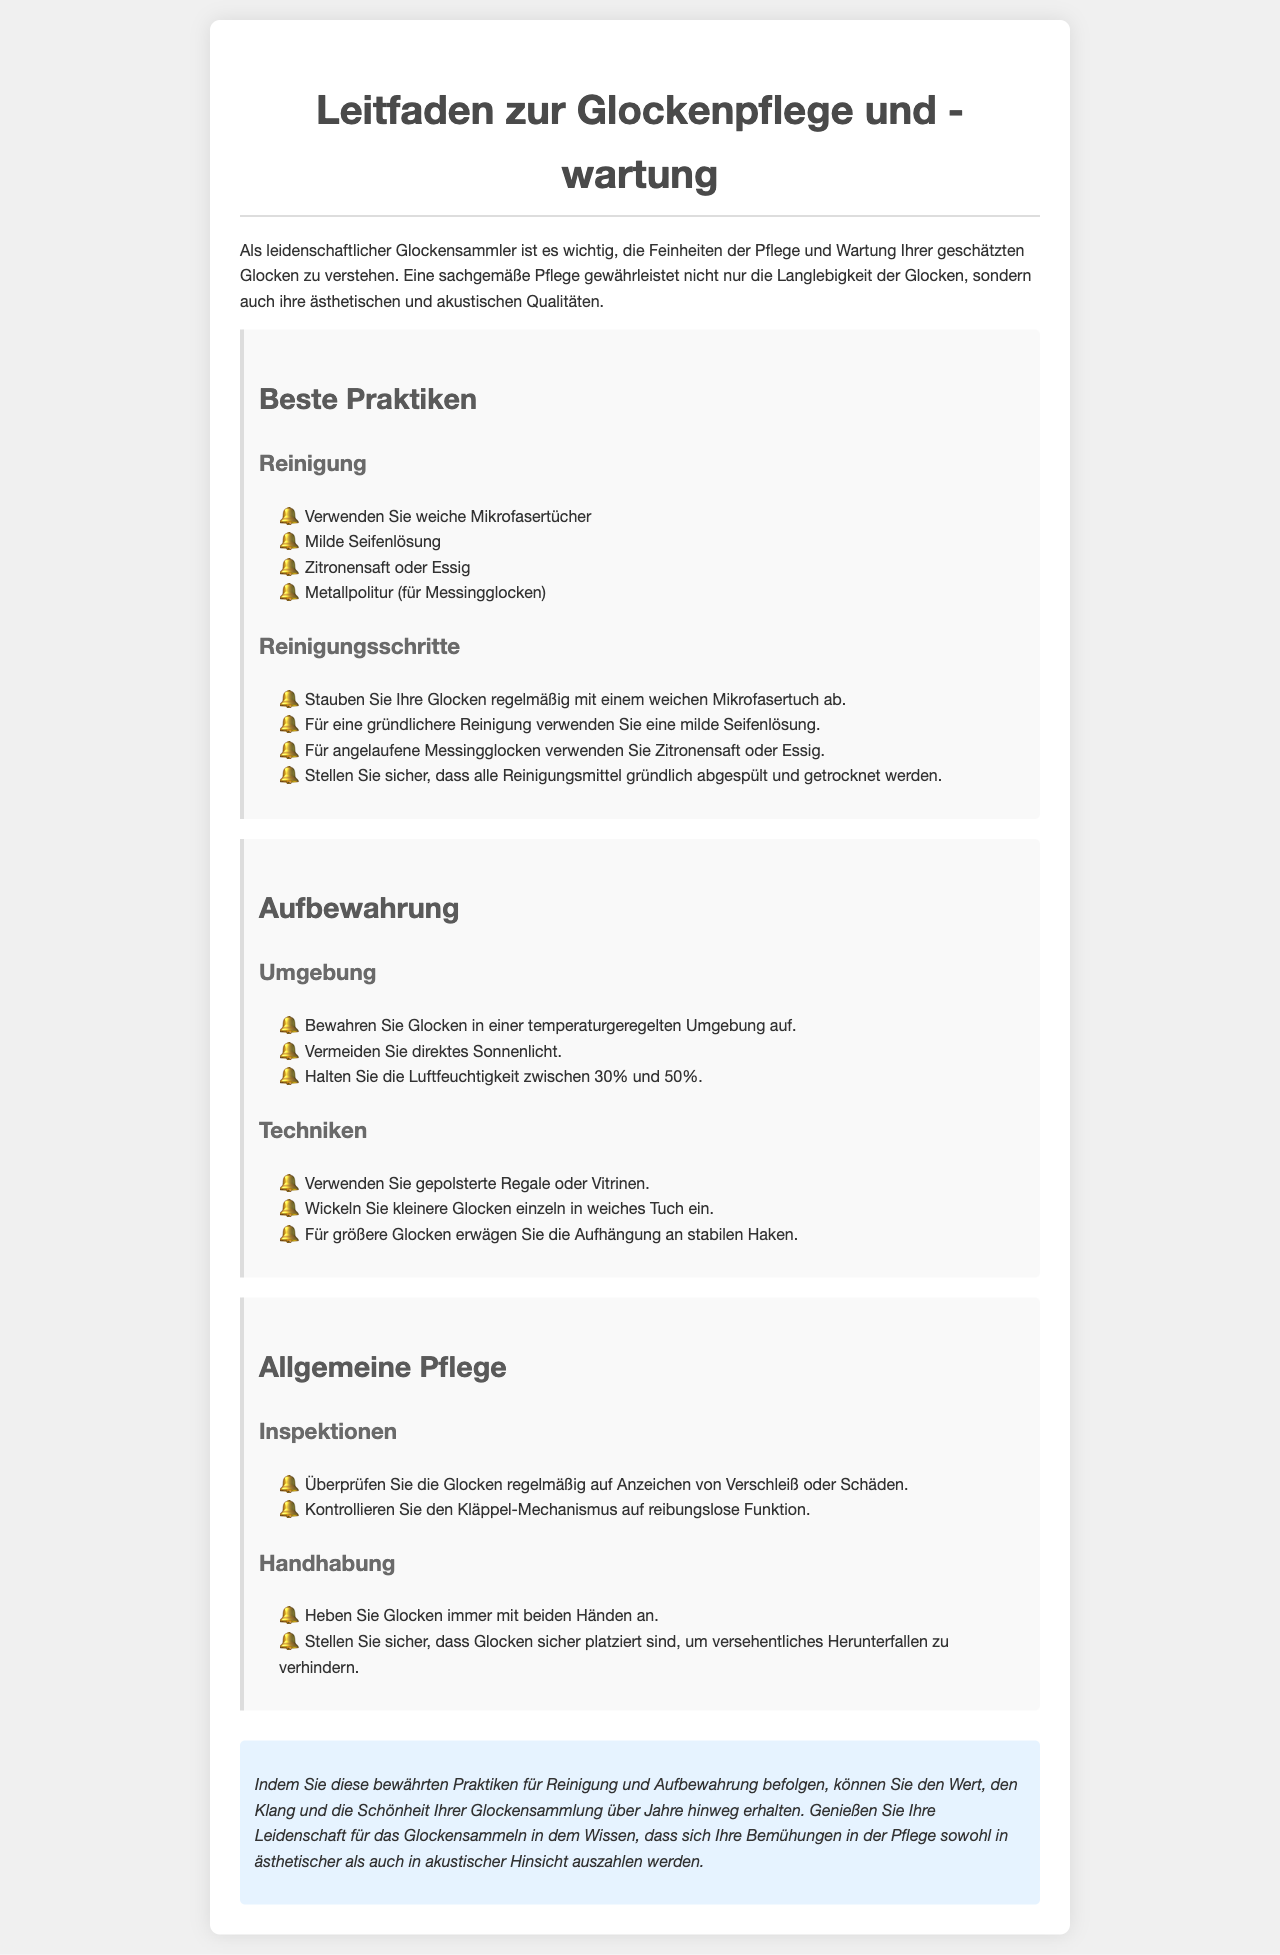was sind die besten Praktiken für die Reinigung? Die besten Praktiken für die Reinigung sind in der Sektion "Reinigung" aufgeführt, einschließlich der Verwendung von weichen Mikrofasertüchern und milder Seifenlösung.
Answer: weiche Mikrofasertücher, milde Seifenlösung wie oft sollten die Glocken auf Verschleiß überprüft werden? Die Dokumentation erwähnt regelmäßige Inspektionen, ohne eine spezifische Häufigkeit anzugeben.
Answer: regelmäßig welche Temperatur sollte für die Aufbewahrung der Glocken idealerweise eingehalten werden? Es wird empfohlen, Glocken in einer temperaturgeregelten Umgebung aufzubewahren.
Answer: temperaturgeregelt welches Material wird für die Reinigung von Messingglocken empfohlen? Für die Reinigung von Messingglocken wird Metallpolitur empfohlen.
Answer: Metallpolitur wie sollten kleinere Glocken gelagert werden? Kleinere Glocken sollten einzeln in weiches Tuch eingewickelt werden.
Answer: einzeln in weiches Tuch was sollte bei der Handhabung von Glocken beachtet werden? Bei der Handhabung sollte darauf geachtet werden, Glocken immer mit beiden Händen anzuheben.
Answer: beide Hände was kann als mildes Reinigungsmittel verwendet werden? Als mildes Reinigungsmittel kann eine milde Seifenlösung verwendet werden.
Answer: milde Seifenlösung wie hoch sollte die Luftfeuchtigkeit für die Lagerung der Glocken sein? Die Luftfeuchtigkeit sollte zwischen 30% und 50% gehalten werden.
Answer: zwischen 30% und 50% 